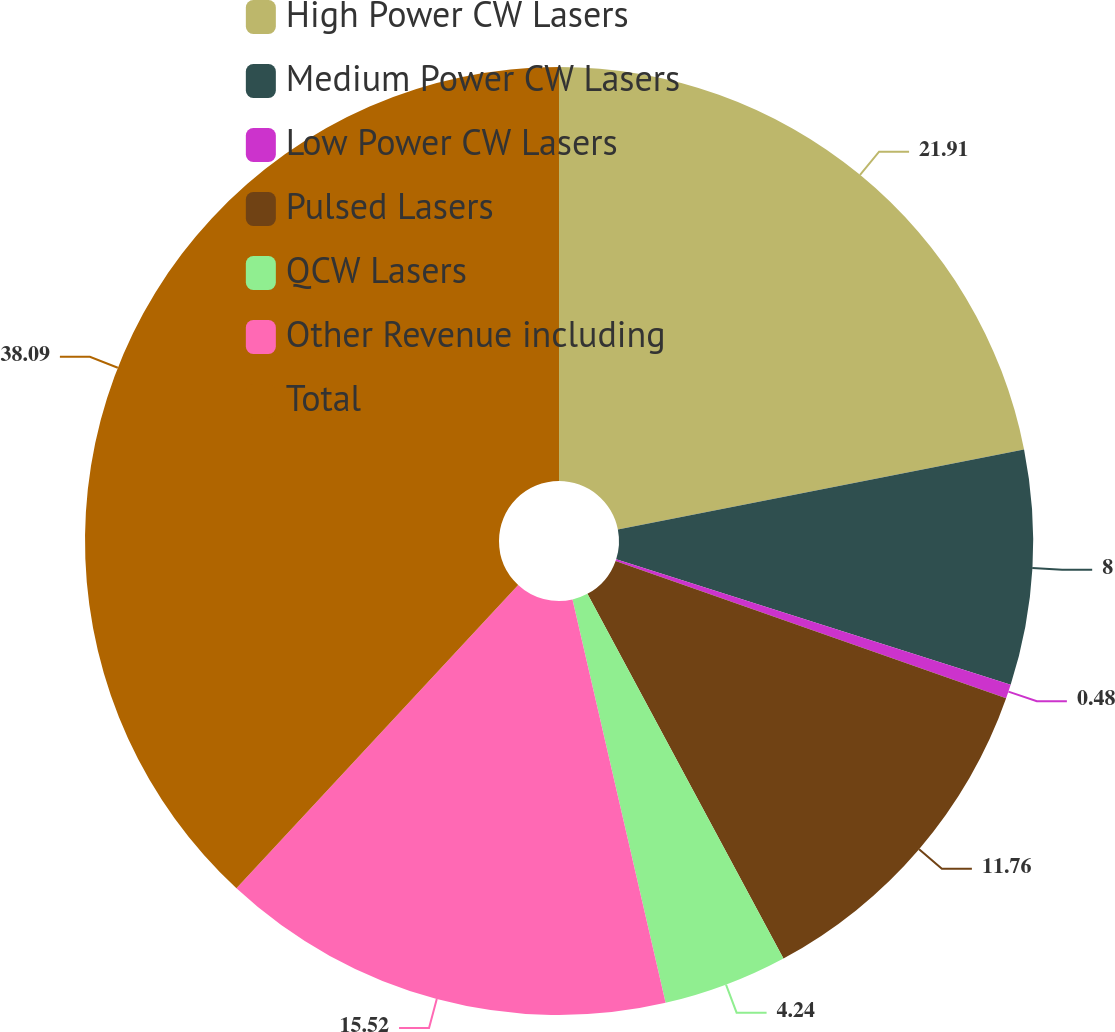<chart> <loc_0><loc_0><loc_500><loc_500><pie_chart><fcel>High Power CW Lasers<fcel>Medium Power CW Lasers<fcel>Low Power CW Lasers<fcel>Pulsed Lasers<fcel>QCW Lasers<fcel>Other Revenue including<fcel>Total<nl><fcel>21.9%<fcel>8.0%<fcel>0.48%<fcel>11.76%<fcel>4.24%<fcel>15.52%<fcel>38.08%<nl></chart> 